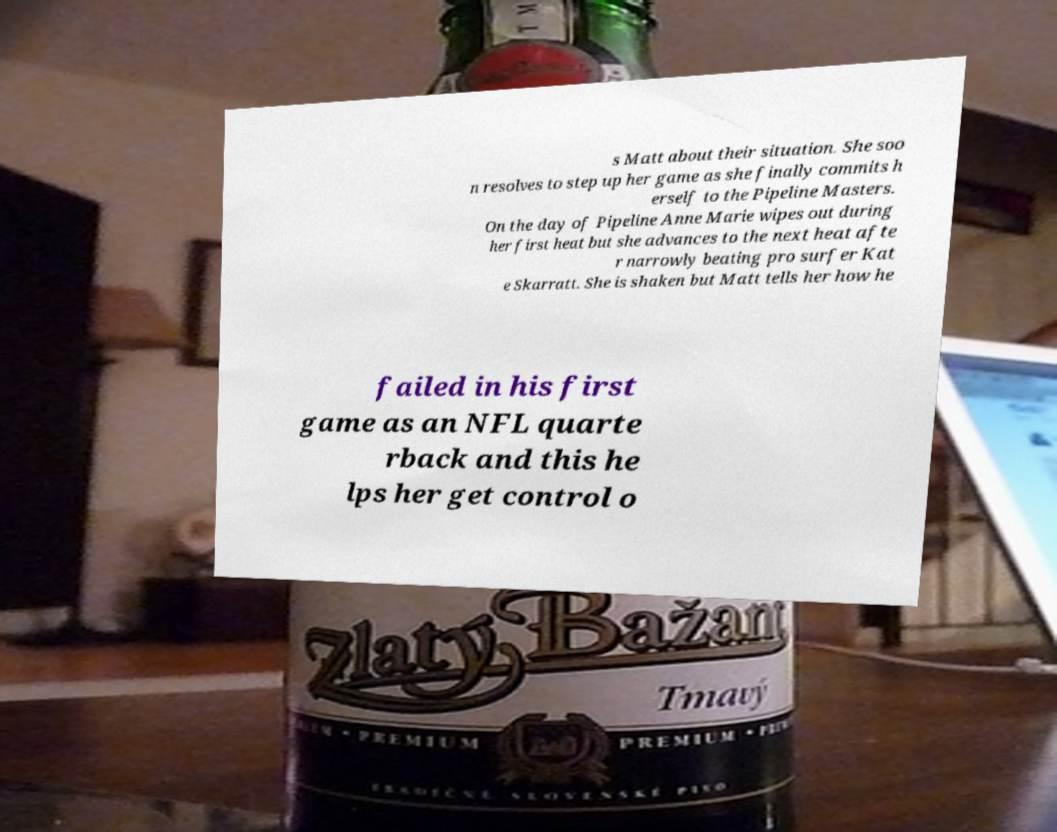Please identify and transcribe the text found in this image. s Matt about their situation. She soo n resolves to step up her game as she finally commits h erself to the Pipeline Masters. On the day of Pipeline Anne Marie wipes out during her first heat but she advances to the next heat afte r narrowly beating pro surfer Kat e Skarratt. She is shaken but Matt tells her how he failed in his first game as an NFL quarte rback and this he lps her get control o 